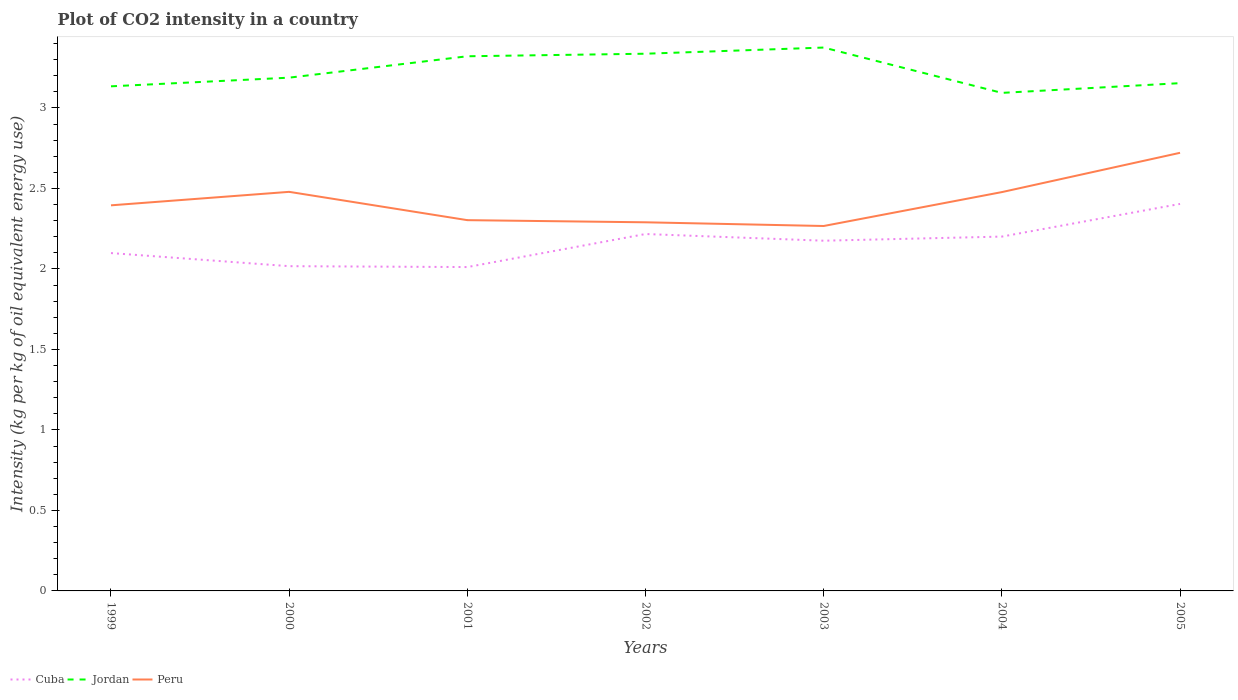Across all years, what is the maximum CO2 intensity in in Peru?
Make the answer very short. 2.27. What is the total CO2 intensity in in Cuba in the graph?
Offer a very short reply. -0.1. What is the difference between the highest and the second highest CO2 intensity in in Cuba?
Offer a terse response. 0.39. What is the difference between the highest and the lowest CO2 intensity in in Jordan?
Provide a succinct answer. 3. Is the CO2 intensity in in Peru strictly greater than the CO2 intensity in in Jordan over the years?
Your response must be concise. Yes. How many lines are there?
Your response must be concise. 3. How many years are there in the graph?
Your answer should be very brief. 7. Does the graph contain grids?
Your answer should be compact. No. Where does the legend appear in the graph?
Offer a terse response. Bottom left. How many legend labels are there?
Make the answer very short. 3. What is the title of the graph?
Offer a very short reply. Plot of CO2 intensity in a country. Does "Eritrea" appear as one of the legend labels in the graph?
Provide a succinct answer. No. What is the label or title of the X-axis?
Offer a terse response. Years. What is the label or title of the Y-axis?
Your response must be concise. Intensity (kg per kg of oil equivalent energy use). What is the Intensity (kg per kg of oil equivalent energy use) of Cuba in 1999?
Your answer should be very brief. 2.1. What is the Intensity (kg per kg of oil equivalent energy use) in Jordan in 1999?
Keep it short and to the point. 3.13. What is the Intensity (kg per kg of oil equivalent energy use) of Peru in 1999?
Your answer should be compact. 2.4. What is the Intensity (kg per kg of oil equivalent energy use) of Cuba in 2000?
Provide a short and direct response. 2.02. What is the Intensity (kg per kg of oil equivalent energy use) of Jordan in 2000?
Ensure brevity in your answer.  3.19. What is the Intensity (kg per kg of oil equivalent energy use) of Peru in 2000?
Provide a succinct answer. 2.48. What is the Intensity (kg per kg of oil equivalent energy use) in Cuba in 2001?
Offer a terse response. 2.01. What is the Intensity (kg per kg of oil equivalent energy use) in Jordan in 2001?
Provide a succinct answer. 3.32. What is the Intensity (kg per kg of oil equivalent energy use) of Peru in 2001?
Your answer should be compact. 2.3. What is the Intensity (kg per kg of oil equivalent energy use) of Cuba in 2002?
Offer a very short reply. 2.22. What is the Intensity (kg per kg of oil equivalent energy use) of Jordan in 2002?
Your response must be concise. 3.34. What is the Intensity (kg per kg of oil equivalent energy use) in Peru in 2002?
Give a very brief answer. 2.29. What is the Intensity (kg per kg of oil equivalent energy use) of Cuba in 2003?
Offer a very short reply. 2.18. What is the Intensity (kg per kg of oil equivalent energy use) in Jordan in 2003?
Your response must be concise. 3.38. What is the Intensity (kg per kg of oil equivalent energy use) of Peru in 2003?
Keep it short and to the point. 2.27. What is the Intensity (kg per kg of oil equivalent energy use) in Cuba in 2004?
Your response must be concise. 2.2. What is the Intensity (kg per kg of oil equivalent energy use) of Jordan in 2004?
Keep it short and to the point. 3.09. What is the Intensity (kg per kg of oil equivalent energy use) of Peru in 2004?
Offer a terse response. 2.48. What is the Intensity (kg per kg of oil equivalent energy use) of Cuba in 2005?
Provide a succinct answer. 2.4. What is the Intensity (kg per kg of oil equivalent energy use) of Jordan in 2005?
Make the answer very short. 3.15. What is the Intensity (kg per kg of oil equivalent energy use) of Peru in 2005?
Provide a succinct answer. 2.72. Across all years, what is the maximum Intensity (kg per kg of oil equivalent energy use) in Cuba?
Make the answer very short. 2.4. Across all years, what is the maximum Intensity (kg per kg of oil equivalent energy use) of Jordan?
Make the answer very short. 3.38. Across all years, what is the maximum Intensity (kg per kg of oil equivalent energy use) in Peru?
Your response must be concise. 2.72. Across all years, what is the minimum Intensity (kg per kg of oil equivalent energy use) in Cuba?
Keep it short and to the point. 2.01. Across all years, what is the minimum Intensity (kg per kg of oil equivalent energy use) of Jordan?
Provide a succinct answer. 3.09. Across all years, what is the minimum Intensity (kg per kg of oil equivalent energy use) in Peru?
Give a very brief answer. 2.27. What is the total Intensity (kg per kg of oil equivalent energy use) of Cuba in the graph?
Offer a terse response. 15.12. What is the total Intensity (kg per kg of oil equivalent energy use) in Jordan in the graph?
Offer a terse response. 22.6. What is the total Intensity (kg per kg of oil equivalent energy use) in Peru in the graph?
Give a very brief answer. 16.93. What is the difference between the Intensity (kg per kg of oil equivalent energy use) in Cuba in 1999 and that in 2000?
Keep it short and to the point. 0.08. What is the difference between the Intensity (kg per kg of oil equivalent energy use) of Jordan in 1999 and that in 2000?
Keep it short and to the point. -0.05. What is the difference between the Intensity (kg per kg of oil equivalent energy use) of Peru in 1999 and that in 2000?
Provide a short and direct response. -0.08. What is the difference between the Intensity (kg per kg of oil equivalent energy use) of Cuba in 1999 and that in 2001?
Provide a short and direct response. 0.09. What is the difference between the Intensity (kg per kg of oil equivalent energy use) in Jordan in 1999 and that in 2001?
Give a very brief answer. -0.19. What is the difference between the Intensity (kg per kg of oil equivalent energy use) in Peru in 1999 and that in 2001?
Your answer should be compact. 0.09. What is the difference between the Intensity (kg per kg of oil equivalent energy use) in Cuba in 1999 and that in 2002?
Offer a very short reply. -0.12. What is the difference between the Intensity (kg per kg of oil equivalent energy use) in Jordan in 1999 and that in 2002?
Provide a short and direct response. -0.2. What is the difference between the Intensity (kg per kg of oil equivalent energy use) of Peru in 1999 and that in 2002?
Your answer should be very brief. 0.11. What is the difference between the Intensity (kg per kg of oil equivalent energy use) of Cuba in 1999 and that in 2003?
Your response must be concise. -0.08. What is the difference between the Intensity (kg per kg of oil equivalent energy use) of Jordan in 1999 and that in 2003?
Offer a terse response. -0.24. What is the difference between the Intensity (kg per kg of oil equivalent energy use) in Peru in 1999 and that in 2003?
Keep it short and to the point. 0.13. What is the difference between the Intensity (kg per kg of oil equivalent energy use) in Cuba in 1999 and that in 2004?
Offer a very short reply. -0.1. What is the difference between the Intensity (kg per kg of oil equivalent energy use) of Jordan in 1999 and that in 2004?
Give a very brief answer. 0.04. What is the difference between the Intensity (kg per kg of oil equivalent energy use) of Peru in 1999 and that in 2004?
Ensure brevity in your answer.  -0.08. What is the difference between the Intensity (kg per kg of oil equivalent energy use) of Cuba in 1999 and that in 2005?
Your answer should be very brief. -0.31. What is the difference between the Intensity (kg per kg of oil equivalent energy use) of Jordan in 1999 and that in 2005?
Your response must be concise. -0.02. What is the difference between the Intensity (kg per kg of oil equivalent energy use) of Peru in 1999 and that in 2005?
Your answer should be compact. -0.33. What is the difference between the Intensity (kg per kg of oil equivalent energy use) of Cuba in 2000 and that in 2001?
Make the answer very short. 0.01. What is the difference between the Intensity (kg per kg of oil equivalent energy use) in Jordan in 2000 and that in 2001?
Offer a terse response. -0.13. What is the difference between the Intensity (kg per kg of oil equivalent energy use) in Peru in 2000 and that in 2001?
Keep it short and to the point. 0.18. What is the difference between the Intensity (kg per kg of oil equivalent energy use) in Cuba in 2000 and that in 2002?
Your answer should be compact. -0.2. What is the difference between the Intensity (kg per kg of oil equivalent energy use) in Jordan in 2000 and that in 2002?
Ensure brevity in your answer.  -0.15. What is the difference between the Intensity (kg per kg of oil equivalent energy use) of Peru in 2000 and that in 2002?
Ensure brevity in your answer.  0.19. What is the difference between the Intensity (kg per kg of oil equivalent energy use) of Cuba in 2000 and that in 2003?
Provide a succinct answer. -0.16. What is the difference between the Intensity (kg per kg of oil equivalent energy use) of Jordan in 2000 and that in 2003?
Provide a succinct answer. -0.19. What is the difference between the Intensity (kg per kg of oil equivalent energy use) in Peru in 2000 and that in 2003?
Offer a terse response. 0.21. What is the difference between the Intensity (kg per kg of oil equivalent energy use) in Cuba in 2000 and that in 2004?
Offer a terse response. -0.18. What is the difference between the Intensity (kg per kg of oil equivalent energy use) of Jordan in 2000 and that in 2004?
Offer a very short reply. 0.09. What is the difference between the Intensity (kg per kg of oil equivalent energy use) in Peru in 2000 and that in 2004?
Your answer should be very brief. 0. What is the difference between the Intensity (kg per kg of oil equivalent energy use) in Cuba in 2000 and that in 2005?
Your answer should be very brief. -0.39. What is the difference between the Intensity (kg per kg of oil equivalent energy use) of Jordan in 2000 and that in 2005?
Provide a succinct answer. 0.03. What is the difference between the Intensity (kg per kg of oil equivalent energy use) of Peru in 2000 and that in 2005?
Give a very brief answer. -0.24. What is the difference between the Intensity (kg per kg of oil equivalent energy use) in Cuba in 2001 and that in 2002?
Make the answer very short. -0.21. What is the difference between the Intensity (kg per kg of oil equivalent energy use) of Jordan in 2001 and that in 2002?
Provide a short and direct response. -0.02. What is the difference between the Intensity (kg per kg of oil equivalent energy use) of Peru in 2001 and that in 2002?
Provide a short and direct response. 0.01. What is the difference between the Intensity (kg per kg of oil equivalent energy use) of Cuba in 2001 and that in 2003?
Make the answer very short. -0.16. What is the difference between the Intensity (kg per kg of oil equivalent energy use) in Jordan in 2001 and that in 2003?
Provide a short and direct response. -0.05. What is the difference between the Intensity (kg per kg of oil equivalent energy use) of Peru in 2001 and that in 2003?
Your answer should be compact. 0.04. What is the difference between the Intensity (kg per kg of oil equivalent energy use) in Cuba in 2001 and that in 2004?
Keep it short and to the point. -0.19. What is the difference between the Intensity (kg per kg of oil equivalent energy use) of Jordan in 2001 and that in 2004?
Provide a short and direct response. 0.23. What is the difference between the Intensity (kg per kg of oil equivalent energy use) of Peru in 2001 and that in 2004?
Give a very brief answer. -0.17. What is the difference between the Intensity (kg per kg of oil equivalent energy use) of Cuba in 2001 and that in 2005?
Make the answer very short. -0.39. What is the difference between the Intensity (kg per kg of oil equivalent energy use) in Jordan in 2001 and that in 2005?
Give a very brief answer. 0.17. What is the difference between the Intensity (kg per kg of oil equivalent energy use) of Peru in 2001 and that in 2005?
Give a very brief answer. -0.42. What is the difference between the Intensity (kg per kg of oil equivalent energy use) of Cuba in 2002 and that in 2003?
Offer a very short reply. 0.04. What is the difference between the Intensity (kg per kg of oil equivalent energy use) in Jordan in 2002 and that in 2003?
Make the answer very short. -0.04. What is the difference between the Intensity (kg per kg of oil equivalent energy use) in Peru in 2002 and that in 2003?
Offer a very short reply. 0.02. What is the difference between the Intensity (kg per kg of oil equivalent energy use) of Cuba in 2002 and that in 2004?
Make the answer very short. 0.02. What is the difference between the Intensity (kg per kg of oil equivalent energy use) of Jordan in 2002 and that in 2004?
Your answer should be compact. 0.24. What is the difference between the Intensity (kg per kg of oil equivalent energy use) of Peru in 2002 and that in 2004?
Keep it short and to the point. -0.19. What is the difference between the Intensity (kg per kg of oil equivalent energy use) in Cuba in 2002 and that in 2005?
Your answer should be very brief. -0.19. What is the difference between the Intensity (kg per kg of oil equivalent energy use) of Jordan in 2002 and that in 2005?
Keep it short and to the point. 0.18. What is the difference between the Intensity (kg per kg of oil equivalent energy use) in Peru in 2002 and that in 2005?
Provide a succinct answer. -0.43. What is the difference between the Intensity (kg per kg of oil equivalent energy use) of Cuba in 2003 and that in 2004?
Make the answer very short. -0.03. What is the difference between the Intensity (kg per kg of oil equivalent energy use) of Jordan in 2003 and that in 2004?
Your response must be concise. 0.28. What is the difference between the Intensity (kg per kg of oil equivalent energy use) of Peru in 2003 and that in 2004?
Give a very brief answer. -0.21. What is the difference between the Intensity (kg per kg of oil equivalent energy use) in Cuba in 2003 and that in 2005?
Provide a succinct answer. -0.23. What is the difference between the Intensity (kg per kg of oil equivalent energy use) in Jordan in 2003 and that in 2005?
Ensure brevity in your answer.  0.22. What is the difference between the Intensity (kg per kg of oil equivalent energy use) of Peru in 2003 and that in 2005?
Your answer should be very brief. -0.45. What is the difference between the Intensity (kg per kg of oil equivalent energy use) of Cuba in 2004 and that in 2005?
Give a very brief answer. -0.2. What is the difference between the Intensity (kg per kg of oil equivalent energy use) in Jordan in 2004 and that in 2005?
Give a very brief answer. -0.06. What is the difference between the Intensity (kg per kg of oil equivalent energy use) of Peru in 2004 and that in 2005?
Your response must be concise. -0.24. What is the difference between the Intensity (kg per kg of oil equivalent energy use) in Cuba in 1999 and the Intensity (kg per kg of oil equivalent energy use) in Jordan in 2000?
Provide a succinct answer. -1.09. What is the difference between the Intensity (kg per kg of oil equivalent energy use) in Cuba in 1999 and the Intensity (kg per kg of oil equivalent energy use) in Peru in 2000?
Provide a succinct answer. -0.38. What is the difference between the Intensity (kg per kg of oil equivalent energy use) of Jordan in 1999 and the Intensity (kg per kg of oil equivalent energy use) of Peru in 2000?
Give a very brief answer. 0.66. What is the difference between the Intensity (kg per kg of oil equivalent energy use) of Cuba in 1999 and the Intensity (kg per kg of oil equivalent energy use) of Jordan in 2001?
Provide a short and direct response. -1.22. What is the difference between the Intensity (kg per kg of oil equivalent energy use) in Cuba in 1999 and the Intensity (kg per kg of oil equivalent energy use) in Peru in 2001?
Ensure brevity in your answer.  -0.2. What is the difference between the Intensity (kg per kg of oil equivalent energy use) of Jordan in 1999 and the Intensity (kg per kg of oil equivalent energy use) of Peru in 2001?
Keep it short and to the point. 0.83. What is the difference between the Intensity (kg per kg of oil equivalent energy use) of Cuba in 1999 and the Intensity (kg per kg of oil equivalent energy use) of Jordan in 2002?
Make the answer very short. -1.24. What is the difference between the Intensity (kg per kg of oil equivalent energy use) in Cuba in 1999 and the Intensity (kg per kg of oil equivalent energy use) in Peru in 2002?
Your answer should be compact. -0.19. What is the difference between the Intensity (kg per kg of oil equivalent energy use) in Jordan in 1999 and the Intensity (kg per kg of oil equivalent energy use) in Peru in 2002?
Make the answer very short. 0.84. What is the difference between the Intensity (kg per kg of oil equivalent energy use) in Cuba in 1999 and the Intensity (kg per kg of oil equivalent energy use) in Jordan in 2003?
Give a very brief answer. -1.28. What is the difference between the Intensity (kg per kg of oil equivalent energy use) in Cuba in 1999 and the Intensity (kg per kg of oil equivalent energy use) in Peru in 2003?
Your response must be concise. -0.17. What is the difference between the Intensity (kg per kg of oil equivalent energy use) in Jordan in 1999 and the Intensity (kg per kg of oil equivalent energy use) in Peru in 2003?
Provide a succinct answer. 0.87. What is the difference between the Intensity (kg per kg of oil equivalent energy use) of Cuba in 1999 and the Intensity (kg per kg of oil equivalent energy use) of Jordan in 2004?
Your answer should be very brief. -0.99. What is the difference between the Intensity (kg per kg of oil equivalent energy use) of Cuba in 1999 and the Intensity (kg per kg of oil equivalent energy use) of Peru in 2004?
Offer a very short reply. -0.38. What is the difference between the Intensity (kg per kg of oil equivalent energy use) of Jordan in 1999 and the Intensity (kg per kg of oil equivalent energy use) of Peru in 2004?
Make the answer very short. 0.66. What is the difference between the Intensity (kg per kg of oil equivalent energy use) in Cuba in 1999 and the Intensity (kg per kg of oil equivalent energy use) in Jordan in 2005?
Provide a succinct answer. -1.06. What is the difference between the Intensity (kg per kg of oil equivalent energy use) in Cuba in 1999 and the Intensity (kg per kg of oil equivalent energy use) in Peru in 2005?
Provide a short and direct response. -0.62. What is the difference between the Intensity (kg per kg of oil equivalent energy use) of Jordan in 1999 and the Intensity (kg per kg of oil equivalent energy use) of Peru in 2005?
Ensure brevity in your answer.  0.41. What is the difference between the Intensity (kg per kg of oil equivalent energy use) of Cuba in 2000 and the Intensity (kg per kg of oil equivalent energy use) of Jordan in 2001?
Make the answer very short. -1.3. What is the difference between the Intensity (kg per kg of oil equivalent energy use) of Cuba in 2000 and the Intensity (kg per kg of oil equivalent energy use) of Peru in 2001?
Provide a succinct answer. -0.29. What is the difference between the Intensity (kg per kg of oil equivalent energy use) of Jordan in 2000 and the Intensity (kg per kg of oil equivalent energy use) of Peru in 2001?
Your answer should be compact. 0.89. What is the difference between the Intensity (kg per kg of oil equivalent energy use) of Cuba in 2000 and the Intensity (kg per kg of oil equivalent energy use) of Jordan in 2002?
Ensure brevity in your answer.  -1.32. What is the difference between the Intensity (kg per kg of oil equivalent energy use) in Cuba in 2000 and the Intensity (kg per kg of oil equivalent energy use) in Peru in 2002?
Your answer should be very brief. -0.27. What is the difference between the Intensity (kg per kg of oil equivalent energy use) in Jordan in 2000 and the Intensity (kg per kg of oil equivalent energy use) in Peru in 2002?
Your answer should be very brief. 0.9. What is the difference between the Intensity (kg per kg of oil equivalent energy use) in Cuba in 2000 and the Intensity (kg per kg of oil equivalent energy use) in Jordan in 2003?
Keep it short and to the point. -1.36. What is the difference between the Intensity (kg per kg of oil equivalent energy use) in Cuba in 2000 and the Intensity (kg per kg of oil equivalent energy use) in Peru in 2003?
Make the answer very short. -0.25. What is the difference between the Intensity (kg per kg of oil equivalent energy use) of Jordan in 2000 and the Intensity (kg per kg of oil equivalent energy use) of Peru in 2003?
Your answer should be compact. 0.92. What is the difference between the Intensity (kg per kg of oil equivalent energy use) of Cuba in 2000 and the Intensity (kg per kg of oil equivalent energy use) of Jordan in 2004?
Your answer should be compact. -1.08. What is the difference between the Intensity (kg per kg of oil equivalent energy use) in Cuba in 2000 and the Intensity (kg per kg of oil equivalent energy use) in Peru in 2004?
Ensure brevity in your answer.  -0.46. What is the difference between the Intensity (kg per kg of oil equivalent energy use) of Jordan in 2000 and the Intensity (kg per kg of oil equivalent energy use) of Peru in 2004?
Offer a terse response. 0.71. What is the difference between the Intensity (kg per kg of oil equivalent energy use) in Cuba in 2000 and the Intensity (kg per kg of oil equivalent energy use) in Jordan in 2005?
Your answer should be compact. -1.14. What is the difference between the Intensity (kg per kg of oil equivalent energy use) in Cuba in 2000 and the Intensity (kg per kg of oil equivalent energy use) in Peru in 2005?
Offer a terse response. -0.7. What is the difference between the Intensity (kg per kg of oil equivalent energy use) of Jordan in 2000 and the Intensity (kg per kg of oil equivalent energy use) of Peru in 2005?
Give a very brief answer. 0.47. What is the difference between the Intensity (kg per kg of oil equivalent energy use) in Cuba in 2001 and the Intensity (kg per kg of oil equivalent energy use) in Jordan in 2002?
Provide a short and direct response. -1.33. What is the difference between the Intensity (kg per kg of oil equivalent energy use) of Cuba in 2001 and the Intensity (kg per kg of oil equivalent energy use) of Peru in 2002?
Give a very brief answer. -0.28. What is the difference between the Intensity (kg per kg of oil equivalent energy use) of Jordan in 2001 and the Intensity (kg per kg of oil equivalent energy use) of Peru in 2002?
Provide a short and direct response. 1.03. What is the difference between the Intensity (kg per kg of oil equivalent energy use) in Cuba in 2001 and the Intensity (kg per kg of oil equivalent energy use) in Jordan in 2003?
Offer a terse response. -1.36. What is the difference between the Intensity (kg per kg of oil equivalent energy use) in Cuba in 2001 and the Intensity (kg per kg of oil equivalent energy use) in Peru in 2003?
Offer a very short reply. -0.26. What is the difference between the Intensity (kg per kg of oil equivalent energy use) in Jordan in 2001 and the Intensity (kg per kg of oil equivalent energy use) in Peru in 2003?
Give a very brief answer. 1.05. What is the difference between the Intensity (kg per kg of oil equivalent energy use) in Cuba in 2001 and the Intensity (kg per kg of oil equivalent energy use) in Jordan in 2004?
Provide a succinct answer. -1.08. What is the difference between the Intensity (kg per kg of oil equivalent energy use) in Cuba in 2001 and the Intensity (kg per kg of oil equivalent energy use) in Peru in 2004?
Offer a terse response. -0.47. What is the difference between the Intensity (kg per kg of oil equivalent energy use) of Jordan in 2001 and the Intensity (kg per kg of oil equivalent energy use) of Peru in 2004?
Your answer should be compact. 0.84. What is the difference between the Intensity (kg per kg of oil equivalent energy use) in Cuba in 2001 and the Intensity (kg per kg of oil equivalent energy use) in Jordan in 2005?
Provide a short and direct response. -1.14. What is the difference between the Intensity (kg per kg of oil equivalent energy use) of Cuba in 2001 and the Intensity (kg per kg of oil equivalent energy use) of Peru in 2005?
Your response must be concise. -0.71. What is the difference between the Intensity (kg per kg of oil equivalent energy use) in Jordan in 2001 and the Intensity (kg per kg of oil equivalent energy use) in Peru in 2005?
Your answer should be very brief. 0.6. What is the difference between the Intensity (kg per kg of oil equivalent energy use) in Cuba in 2002 and the Intensity (kg per kg of oil equivalent energy use) in Jordan in 2003?
Offer a terse response. -1.16. What is the difference between the Intensity (kg per kg of oil equivalent energy use) of Cuba in 2002 and the Intensity (kg per kg of oil equivalent energy use) of Peru in 2003?
Your response must be concise. -0.05. What is the difference between the Intensity (kg per kg of oil equivalent energy use) in Jordan in 2002 and the Intensity (kg per kg of oil equivalent energy use) in Peru in 2003?
Offer a terse response. 1.07. What is the difference between the Intensity (kg per kg of oil equivalent energy use) of Cuba in 2002 and the Intensity (kg per kg of oil equivalent energy use) of Jordan in 2004?
Your answer should be compact. -0.88. What is the difference between the Intensity (kg per kg of oil equivalent energy use) of Cuba in 2002 and the Intensity (kg per kg of oil equivalent energy use) of Peru in 2004?
Give a very brief answer. -0.26. What is the difference between the Intensity (kg per kg of oil equivalent energy use) in Jordan in 2002 and the Intensity (kg per kg of oil equivalent energy use) in Peru in 2004?
Provide a succinct answer. 0.86. What is the difference between the Intensity (kg per kg of oil equivalent energy use) of Cuba in 2002 and the Intensity (kg per kg of oil equivalent energy use) of Jordan in 2005?
Provide a succinct answer. -0.94. What is the difference between the Intensity (kg per kg of oil equivalent energy use) of Cuba in 2002 and the Intensity (kg per kg of oil equivalent energy use) of Peru in 2005?
Make the answer very short. -0.5. What is the difference between the Intensity (kg per kg of oil equivalent energy use) of Jordan in 2002 and the Intensity (kg per kg of oil equivalent energy use) of Peru in 2005?
Provide a short and direct response. 0.62. What is the difference between the Intensity (kg per kg of oil equivalent energy use) of Cuba in 2003 and the Intensity (kg per kg of oil equivalent energy use) of Jordan in 2004?
Ensure brevity in your answer.  -0.92. What is the difference between the Intensity (kg per kg of oil equivalent energy use) of Cuba in 2003 and the Intensity (kg per kg of oil equivalent energy use) of Peru in 2004?
Your answer should be compact. -0.3. What is the difference between the Intensity (kg per kg of oil equivalent energy use) of Jordan in 2003 and the Intensity (kg per kg of oil equivalent energy use) of Peru in 2004?
Provide a succinct answer. 0.9. What is the difference between the Intensity (kg per kg of oil equivalent energy use) in Cuba in 2003 and the Intensity (kg per kg of oil equivalent energy use) in Jordan in 2005?
Provide a short and direct response. -0.98. What is the difference between the Intensity (kg per kg of oil equivalent energy use) in Cuba in 2003 and the Intensity (kg per kg of oil equivalent energy use) in Peru in 2005?
Provide a succinct answer. -0.55. What is the difference between the Intensity (kg per kg of oil equivalent energy use) of Jordan in 2003 and the Intensity (kg per kg of oil equivalent energy use) of Peru in 2005?
Offer a very short reply. 0.65. What is the difference between the Intensity (kg per kg of oil equivalent energy use) in Cuba in 2004 and the Intensity (kg per kg of oil equivalent energy use) in Jordan in 2005?
Offer a terse response. -0.95. What is the difference between the Intensity (kg per kg of oil equivalent energy use) in Cuba in 2004 and the Intensity (kg per kg of oil equivalent energy use) in Peru in 2005?
Your response must be concise. -0.52. What is the difference between the Intensity (kg per kg of oil equivalent energy use) in Jordan in 2004 and the Intensity (kg per kg of oil equivalent energy use) in Peru in 2005?
Offer a very short reply. 0.37. What is the average Intensity (kg per kg of oil equivalent energy use) of Cuba per year?
Make the answer very short. 2.16. What is the average Intensity (kg per kg of oil equivalent energy use) in Jordan per year?
Ensure brevity in your answer.  3.23. What is the average Intensity (kg per kg of oil equivalent energy use) of Peru per year?
Your response must be concise. 2.42. In the year 1999, what is the difference between the Intensity (kg per kg of oil equivalent energy use) in Cuba and Intensity (kg per kg of oil equivalent energy use) in Jordan?
Ensure brevity in your answer.  -1.04. In the year 1999, what is the difference between the Intensity (kg per kg of oil equivalent energy use) of Cuba and Intensity (kg per kg of oil equivalent energy use) of Peru?
Provide a succinct answer. -0.3. In the year 1999, what is the difference between the Intensity (kg per kg of oil equivalent energy use) in Jordan and Intensity (kg per kg of oil equivalent energy use) in Peru?
Make the answer very short. 0.74. In the year 2000, what is the difference between the Intensity (kg per kg of oil equivalent energy use) of Cuba and Intensity (kg per kg of oil equivalent energy use) of Jordan?
Offer a terse response. -1.17. In the year 2000, what is the difference between the Intensity (kg per kg of oil equivalent energy use) of Cuba and Intensity (kg per kg of oil equivalent energy use) of Peru?
Keep it short and to the point. -0.46. In the year 2000, what is the difference between the Intensity (kg per kg of oil equivalent energy use) in Jordan and Intensity (kg per kg of oil equivalent energy use) in Peru?
Provide a succinct answer. 0.71. In the year 2001, what is the difference between the Intensity (kg per kg of oil equivalent energy use) in Cuba and Intensity (kg per kg of oil equivalent energy use) in Jordan?
Give a very brief answer. -1.31. In the year 2001, what is the difference between the Intensity (kg per kg of oil equivalent energy use) in Cuba and Intensity (kg per kg of oil equivalent energy use) in Peru?
Provide a succinct answer. -0.29. In the year 2001, what is the difference between the Intensity (kg per kg of oil equivalent energy use) in Jordan and Intensity (kg per kg of oil equivalent energy use) in Peru?
Provide a succinct answer. 1.02. In the year 2002, what is the difference between the Intensity (kg per kg of oil equivalent energy use) of Cuba and Intensity (kg per kg of oil equivalent energy use) of Jordan?
Your answer should be very brief. -1.12. In the year 2002, what is the difference between the Intensity (kg per kg of oil equivalent energy use) of Cuba and Intensity (kg per kg of oil equivalent energy use) of Peru?
Your answer should be compact. -0.07. In the year 2002, what is the difference between the Intensity (kg per kg of oil equivalent energy use) of Jordan and Intensity (kg per kg of oil equivalent energy use) of Peru?
Provide a short and direct response. 1.05. In the year 2003, what is the difference between the Intensity (kg per kg of oil equivalent energy use) of Cuba and Intensity (kg per kg of oil equivalent energy use) of Jordan?
Make the answer very short. -1.2. In the year 2003, what is the difference between the Intensity (kg per kg of oil equivalent energy use) in Cuba and Intensity (kg per kg of oil equivalent energy use) in Peru?
Provide a short and direct response. -0.09. In the year 2003, what is the difference between the Intensity (kg per kg of oil equivalent energy use) in Jordan and Intensity (kg per kg of oil equivalent energy use) in Peru?
Provide a succinct answer. 1.11. In the year 2004, what is the difference between the Intensity (kg per kg of oil equivalent energy use) in Cuba and Intensity (kg per kg of oil equivalent energy use) in Jordan?
Offer a very short reply. -0.89. In the year 2004, what is the difference between the Intensity (kg per kg of oil equivalent energy use) in Cuba and Intensity (kg per kg of oil equivalent energy use) in Peru?
Provide a short and direct response. -0.28. In the year 2004, what is the difference between the Intensity (kg per kg of oil equivalent energy use) in Jordan and Intensity (kg per kg of oil equivalent energy use) in Peru?
Provide a short and direct response. 0.62. In the year 2005, what is the difference between the Intensity (kg per kg of oil equivalent energy use) in Cuba and Intensity (kg per kg of oil equivalent energy use) in Jordan?
Offer a very short reply. -0.75. In the year 2005, what is the difference between the Intensity (kg per kg of oil equivalent energy use) of Cuba and Intensity (kg per kg of oil equivalent energy use) of Peru?
Your answer should be compact. -0.32. In the year 2005, what is the difference between the Intensity (kg per kg of oil equivalent energy use) of Jordan and Intensity (kg per kg of oil equivalent energy use) of Peru?
Keep it short and to the point. 0.43. What is the ratio of the Intensity (kg per kg of oil equivalent energy use) in Cuba in 1999 to that in 2000?
Give a very brief answer. 1.04. What is the ratio of the Intensity (kg per kg of oil equivalent energy use) of Jordan in 1999 to that in 2000?
Your answer should be very brief. 0.98. What is the ratio of the Intensity (kg per kg of oil equivalent energy use) in Peru in 1999 to that in 2000?
Your response must be concise. 0.97. What is the ratio of the Intensity (kg per kg of oil equivalent energy use) in Cuba in 1999 to that in 2001?
Keep it short and to the point. 1.04. What is the ratio of the Intensity (kg per kg of oil equivalent energy use) in Jordan in 1999 to that in 2001?
Provide a short and direct response. 0.94. What is the ratio of the Intensity (kg per kg of oil equivalent energy use) of Cuba in 1999 to that in 2002?
Your answer should be compact. 0.95. What is the ratio of the Intensity (kg per kg of oil equivalent energy use) of Jordan in 1999 to that in 2002?
Your response must be concise. 0.94. What is the ratio of the Intensity (kg per kg of oil equivalent energy use) in Peru in 1999 to that in 2002?
Offer a very short reply. 1.05. What is the ratio of the Intensity (kg per kg of oil equivalent energy use) in Cuba in 1999 to that in 2003?
Your response must be concise. 0.96. What is the ratio of the Intensity (kg per kg of oil equivalent energy use) of Jordan in 1999 to that in 2003?
Ensure brevity in your answer.  0.93. What is the ratio of the Intensity (kg per kg of oil equivalent energy use) of Peru in 1999 to that in 2003?
Your answer should be compact. 1.06. What is the ratio of the Intensity (kg per kg of oil equivalent energy use) in Cuba in 1999 to that in 2004?
Your answer should be compact. 0.95. What is the ratio of the Intensity (kg per kg of oil equivalent energy use) in Jordan in 1999 to that in 2004?
Ensure brevity in your answer.  1.01. What is the ratio of the Intensity (kg per kg of oil equivalent energy use) of Peru in 1999 to that in 2004?
Offer a very short reply. 0.97. What is the ratio of the Intensity (kg per kg of oil equivalent energy use) of Cuba in 1999 to that in 2005?
Offer a terse response. 0.87. What is the ratio of the Intensity (kg per kg of oil equivalent energy use) of Peru in 1999 to that in 2005?
Provide a succinct answer. 0.88. What is the ratio of the Intensity (kg per kg of oil equivalent energy use) of Jordan in 2000 to that in 2001?
Ensure brevity in your answer.  0.96. What is the ratio of the Intensity (kg per kg of oil equivalent energy use) of Peru in 2000 to that in 2001?
Offer a terse response. 1.08. What is the ratio of the Intensity (kg per kg of oil equivalent energy use) of Cuba in 2000 to that in 2002?
Your answer should be compact. 0.91. What is the ratio of the Intensity (kg per kg of oil equivalent energy use) in Jordan in 2000 to that in 2002?
Make the answer very short. 0.96. What is the ratio of the Intensity (kg per kg of oil equivalent energy use) in Peru in 2000 to that in 2002?
Offer a very short reply. 1.08. What is the ratio of the Intensity (kg per kg of oil equivalent energy use) in Cuba in 2000 to that in 2003?
Provide a succinct answer. 0.93. What is the ratio of the Intensity (kg per kg of oil equivalent energy use) of Jordan in 2000 to that in 2003?
Offer a terse response. 0.94. What is the ratio of the Intensity (kg per kg of oil equivalent energy use) in Peru in 2000 to that in 2003?
Provide a succinct answer. 1.09. What is the ratio of the Intensity (kg per kg of oil equivalent energy use) in Cuba in 2000 to that in 2004?
Give a very brief answer. 0.92. What is the ratio of the Intensity (kg per kg of oil equivalent energy use) of Jordan in 2000 to that in 2004?
Keep it short and to the point. 1.03. What is the ratio of the Intensity (kg per kg of oil equivalent energy use) in Peru in 2000 to that in 2004?
Your answer should be very brief. 1. What is the ratio of the Intensity (kg per kg of oil equivalent energy use) of Cuba in 2000 to that in 2005?
Make the answer very short. 0.84. What is the ratio of the Intensity (kg per kg of oil equivalent energy use) of Jordan in 2000 to that in 2005?
Offer a very short reply. 1.01. What is the ratio of the Intensity (kg per kg of oil equivalent energy use) in Peru in 2000 to that in 2005?
Offer a very short reply. 0.91. What is the ratio of the Intensity (kg per kg of oil equivalent energy use) of Cuba in 2001 to that in 2002?
Offer a terse response. 0.91. What is the ratio of the Intensity (kg per kg of oil equivalent energy use) in Jordan in 2001 to that in 2002?
Your answer should be compact. 1. What is the ratio of the Intensity (kg per kg of oil equivalent energy use) of Peru in 2001 to that in 2002?
Ensure brevity in your answer.  1.01. What is the ratio of the Intensity (kg per kg of oil equivalent energy use) of Cuba in 2001 to that in 2003?
Your response must be concise. 0.92. What is the ratio of the Intensity (kg per kg of oil equivalent energy use) of Cuba in 2001 to that in 2004?
Offer a terse response. 0.91. What is the ratio of the Intensity (kg per kg of oil equivalent energy use) of Jordan in 2001 to that in 2004?
Give a very brief answer. 1.07. What is the ratio of the Intensity (kg per kg of oil equivalent energy use) in Peru in 2001 to that in 2004?
Ensure brevity in your answer.  0.93. What is the ratio of the Intensity (kg per kg of oil equivalent energy use) in Cuba in 2001 to that in 2005?
Make the answer very short. 0.84. What is the ratio of the Intensity (kg per kg of oil equivalent energy use) in Jordan in 2001 to that in 2005?
Your answer should be compact. 1.05. What is the ratio of the Intensity (kg per kg of oil equivalent energy use) of Peru in 2001 to that in 2005?
Your response must be concise. 0.85. What is the ratio of the Intensity (kg per kg of oil equivalent energy use) in Cuba in 2002 to that in 2003?
Offer a terse response. 1.02. What is the ratio of the Intensity (kg per kg of oil equivalent energy use) of Jordan in 2002 to that in 2003?
Offer a terse response. 0.99. What is the ratio of the Intensity (kg per kg of oil equivalent energy use) in Peru in 2002 to that in 2003?
Make the answer very short. 1.01. What is the ratio of the Intensity (kg per kg of oil equivalent energy use) in Cuba in 2002 to that in 2004?
Your answer should be compact. 1.01. What is the ratio of the Intensity (kg per kg of oil equivalent energy use) of Jordan in 2002 to that in 2004?
Offer a very short reply. 1.08. What is the ratio of the Intensity (kg per kg of oil equivalent energy use) of Peru in 2002 to that in 2004?
Make the answer very short. 0.92. What is the ratio of the Intensity (kg per kg of oil equivalent energy use) in Cuba in 2002 to that in 2005?
Your answer should be compact. 0.92. What is the ratio of the Intensity (kg per kg of oil equivalent energy use) of Jordan in 2002 to that in 2005?
Keep it short and to the point. 1.06. What is the ratio of the Intensity (kg per kg of oil equivalent energy use) in Peru in 2002 to that in 2005?
Your response must be concise. 0.84. What is the ratio of the Intensity (kg per kg of oil equivalent energy use) in Cuba in 2003 to that in 2004?
Your answer should be very brief. 0.99. What is the ratio of the Intensity (kg per kg of oil equivalent energy use) of Jordan in 2003 to that in 2004?
Offer a very short reply. 1.09. What is the ratio of the Intensity (kg per kg of oil equivalent energy use) of Peru in 2003 to that in 2004?
Offer a terse response. 0.92. What is the ratio of the Intensity (kg per kg of oil equivalent energy use) in Cuba in 2003 to that in 2005?
Your answer should be very brief. 0.9. What is the ratio of the Intensity (kg per kg of oil equivalent energy use) of Jordan in 2003 to that in 2005?
Offer a very short reply. 1.07. What is the ratio of the Intensity (kg per kg of oil equivalent energy use) of Peru in 2003 to that in 2005?
Your answer should be very brief. 0.83. What is the ratio of the Intensity (kg per kg of oil equivalent energy use) of Cuba in 2004 to that in 2005?
Offer a terse response. 0.92. What is the ratio of the Intensity (kg per kg of oil equivalent energy use) in Jordan in 2004 to that in 2005?
Offer a very short reply. 0.98. What is the ratio of the Intensity (kg per kg of oil equivalent energy use) of Peru in 2004 to that in 2005?
Provide a short and direct response. 0.91. What is the difference between the highest and the second highest Intensity (kg per kg of oil equivalent energy use) in Cuba?
Your answer should be compact. 0.19. What is the difference between the highest and the second highest Intensity (kg per kg of oil equivalent energy use) of Jordan?
Your response must be concise. 0.04. What is the difference between the highest and the second highest Intensity (kg per kg of oil equivalent energy use) of Peru?
Offer a terse response. 0.24. What is the difference between the highest and the lowest Intensity (kg per kg of oil equivalent energy use) in Cuba?
Your response must be concise. 0.39. What is the difference between the highest and the lowest Intensity (kg per kg of oil equivalent energy use) in Jordan?
Keep it short and to the point. 0.28. What is the difference between the highest and the lowest Intensity (kg per kg of oil equivalent energy use) in Peru?
Provide a short and direct response. 0.45. 